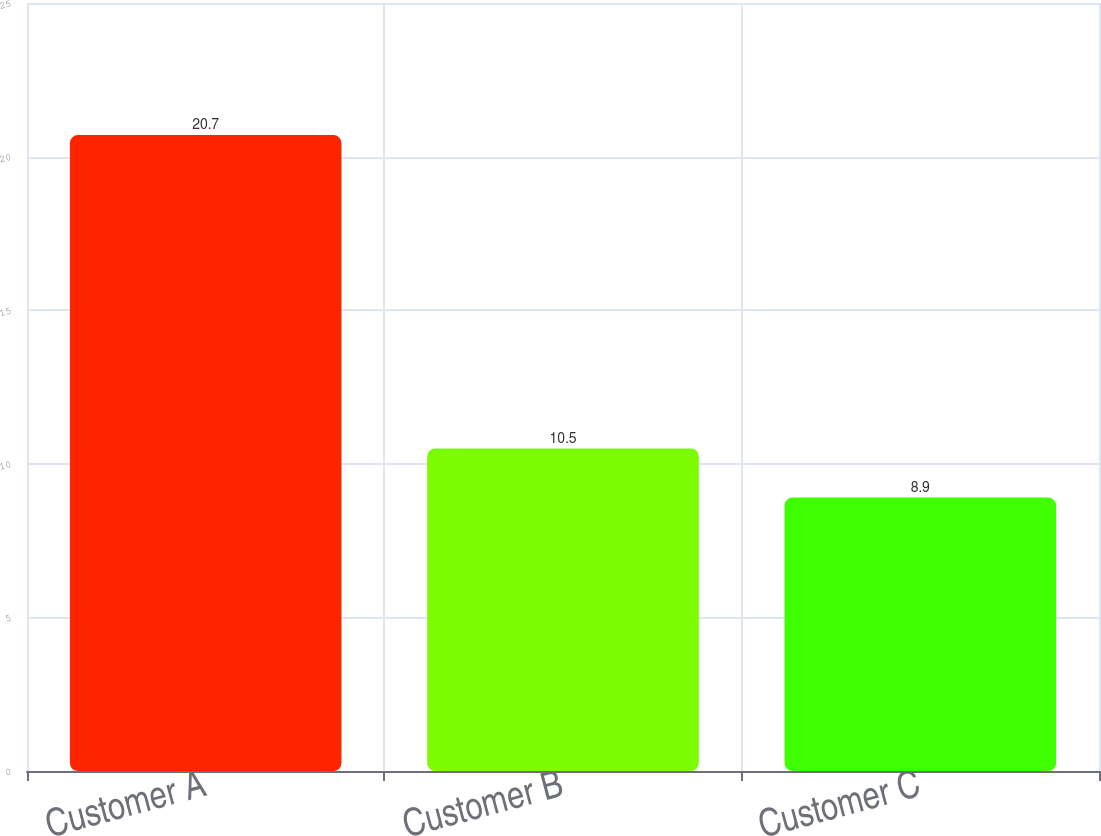<chart> <loc_0><loc_0><loc_500><loc_500><bar_chart><fcel>Customer A<fcel>Customer B<fcel>Customer C<nl><fcel>20.7<fcel>10.5<fcel>8.9<nl></chart> 